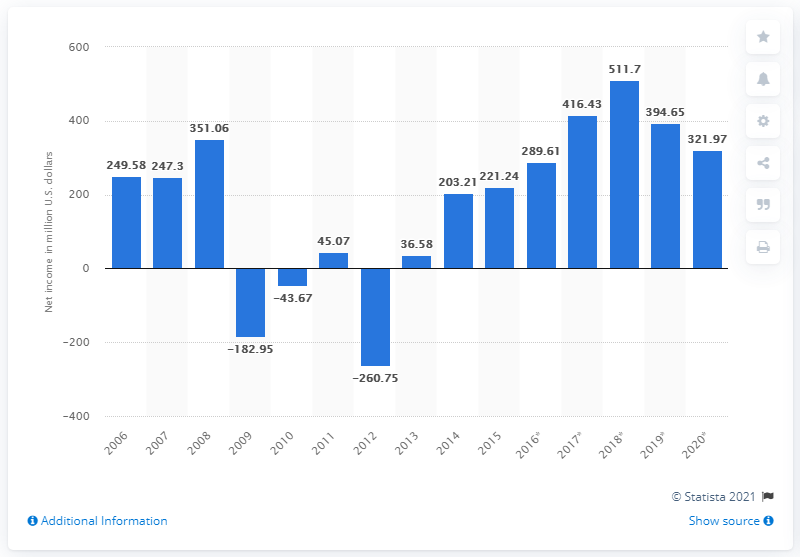Point out several critical features in this image. In 2020, Yamaha Corporation recorded a net income of 321.97 million U.S. dollars. 